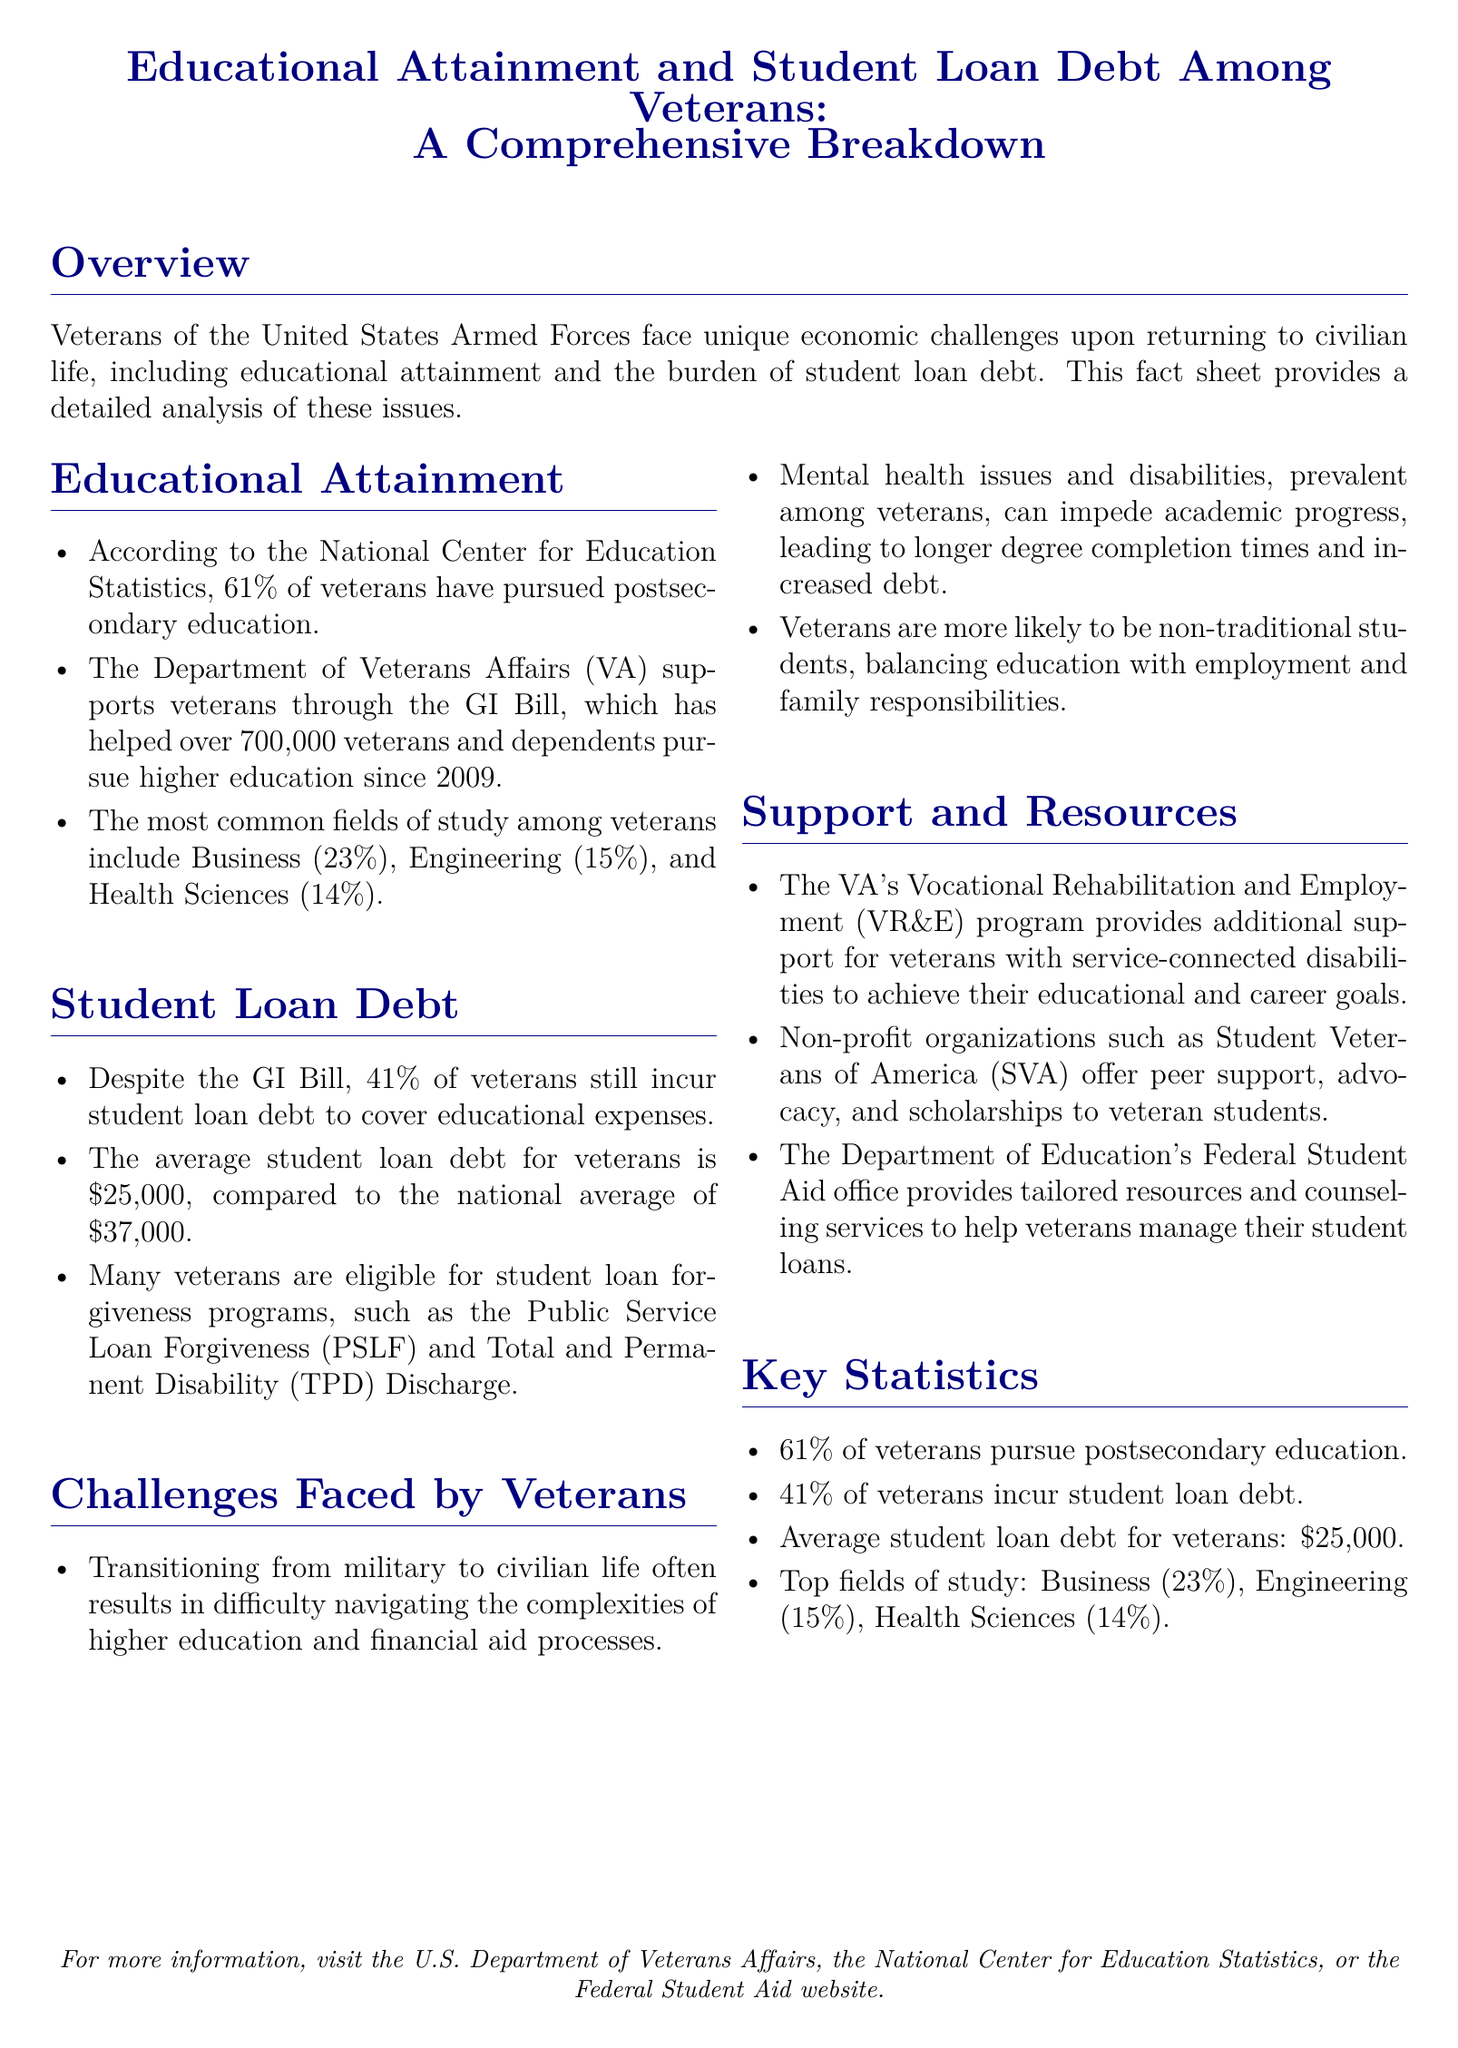what percentage of veterans pursue postsecondary education? The document states that 61% of veterans have pursued postsecondary education.
Answer: 61% what is the average student loan debt for veterans? According to the document, the average student loan debt for veterans is $25,000.
Answer: $25,000 what field of study has the highest percentage among veterans? The highest percentage field of study among veterans is Business at 23%.
Answer: Business what percentage of veterans incur student loan debt? The document notes that 41% of veterans still incur student loan debt.
Answer: 41% which program provides support for veterans with service-connected disabilities? The document mentions the VA's Vocational Rehabilitation and Employment program.
Answer: VR&E how has the GI Bill helped veterans since 2009? The GI Bill has helped over 700,000 veterans and dependents pursue higher education since 2009.
Answer: 700,000 what mental health issues can affect veterans' academic progress? The document refers to mental health issues that can impede academic progress for veterans.
Answer: Mental health issues why might veterans take longer to complete their degrees? Veterans may experience longer degree completion times due to mental health issues and disabilities.
Answer: Mental health issues and disabilities 